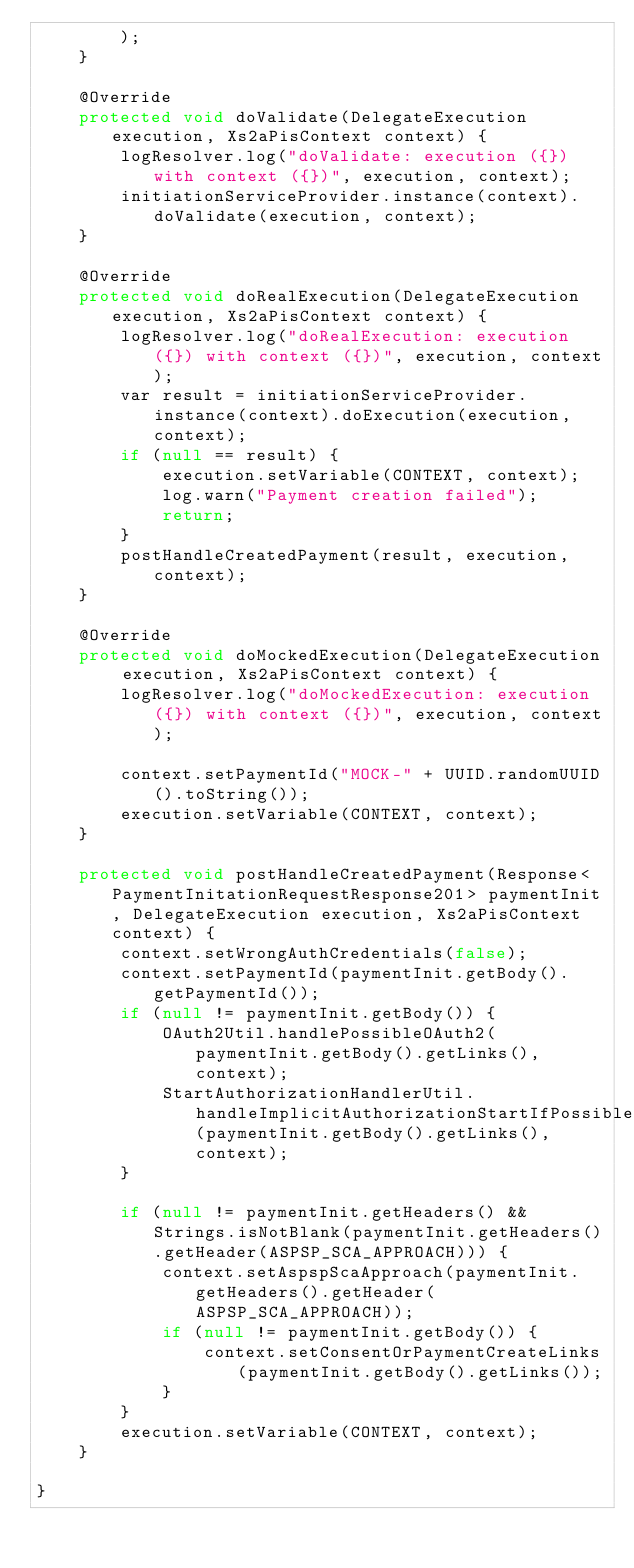Convert code to text. <code><loc_0><loc_0><loc_500><loc_500><_Java_>        );
    }

    @Override
    protected void doValidate(DelegateExecution execution, Xs2aPisContext context) {
        logResolver.log("doValidate: execution ({}) with context ({})", execution, context);
        initiationServiceProvider.instance(context).doValidate(execution, context);
    }

    @Override
    protected void doRealExecution(DelegateExecution execution, Xs2aPisContext context) {
        logResolver.log("doRealExecution: execution ({}) with context ({})", execution, context);
        var result = initiationServiceProvider.instance(context).doExecution(execution, context);
        if (null == result) {
            execution.setVariable(CONTEXT, context);
            log.warn("Payment creation failed");
            return;
        }
        postHandleCreatedPayment(result, execution, context);
    }

    @Override
    protected void doMockedExecution(DelegateExecution execution, Xs2aPisContext context) {
        logResolver.log("doMockedExecution: execution ({}) with context ({})", execution, context);

        context.setPaymentId("MOCK-" + UUID.randomUUID().toString());
        execution.setVariable(CONTEXT, context);
    }

    protected void postHandleCreatedPayment(Response<PaymentInitationRequestResponse201> paymentInit, DelegateExecution execution, Xs2aPisContext context) {
        context.setWrongAuthCredentials(false);
        context.setPaymentId(paymentInit.getBody().getPaymentId());
        if (null != paymentInit.getBody()) {
            OAuth2Util.handlePossibleOAuth2(paymentInit.getBody().getLinks(), context);
            StartAuthorizationHandlerUtil.handleImplicitAuthorizationStartIfPossible(paymentInit.getBody().getLinks(), context);
        }

        if (null != paymentInit.getHeaders() && Strings.isNotBlank(paymentInit.getHeaders().getHeader(ASPSP_SCA_APPROACH))) {
            context.setAspspScaApproach(paymentInit.getHeaders().getHeader(ASPSP_SCA_APPROACH));
            if (null != paymentInit.getBody()) {
                context.setConsentOrPaymentCreateLinks(paymentInit.getBody().getLinks());
            }
        }
        execution.setVariable(CONTEXT, context);
    }

}
</code> 